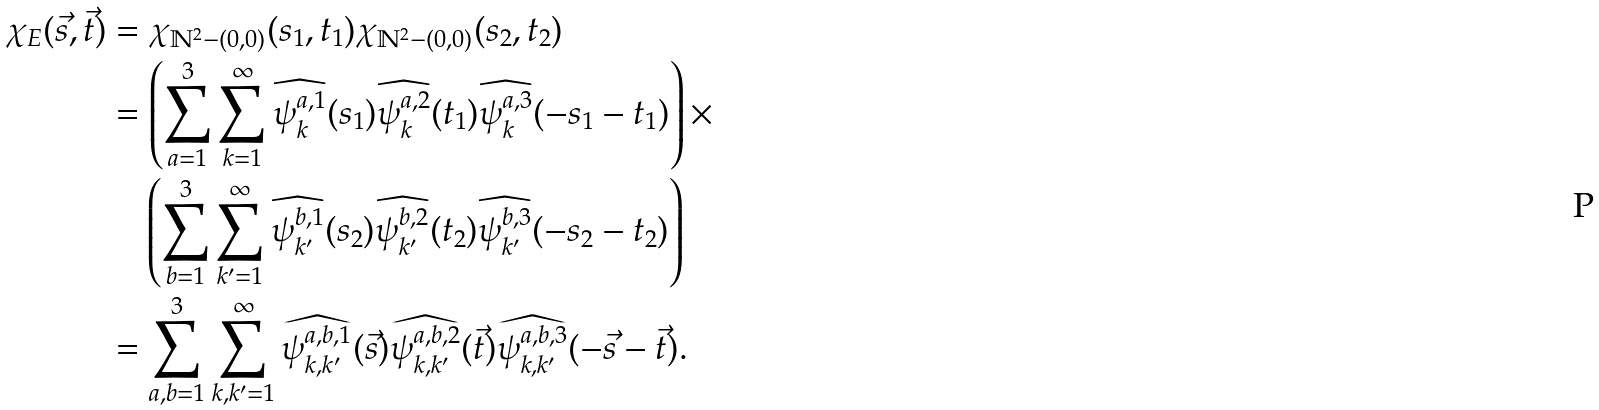Convert formula to latex. <formula><loc_0><loc_0><loc_500><loc_500>\chi _ { E } ( \vec { s } , \vec { t } ) & = \chi _ { \mathbb { N } ^ { 2 } - ( 0 , 0 ) } ( s _ { 1 } , t _ { 1 } ) \chi _ { \mathbb { N } ^ { 2 } - ( 0 , 0 ) } ( s _ { 2 } , t _ { 2 } ) \\ & = \left ( \sum _ { a = 1 } ^ { 3 } \sum _ { k = 1 } ^ { \infty } \widehat { \psi ^ { a , 1 } _ { k } } ( s _ { 1 } ) \widehat { \psi ^ { a , 2 } _ { k } } ( t _ { 1 } ) \widehat { \psi ^ { a , 3 } _ { k } } ( - s _ { 1 } - t _ { 1 } ) \right ) \times \\ & \quad \left ( \sum _ { b = 1 } ^ { 3 } \sum _ { k ^ { \prime } = 1 } ^ { \infty } \widehat { \psi ^ { b , 1 } _ { k ^ { \prime } } } ( s _ { 2 } ) \widehat { \psi ^ { b , 2 } _ { k ^ { \prime } } } ( t _ { 2 } ) \widehat { \psi ^ { b , 3 } _ { k ^ { \prime } } } ( - s _ { 2 } - t _ { 2 } ) \right ) \\ & = \sum _ { a , b = 1 } ^ { 3 } \sum _ { k , k ^ { \prime } = 1 } ^ { \infty } \widehat { \psi ^ { a , b , 1 } _ { k , k ^ { \prime } } } ( \vec { s } ) \widehat { \psi ^ { a , b , 2 } _ { k , k ^ { \prime } } } ( \vec { t } ) \widehat { \psi ^ { a , b , 3 } _ { k , k ^ { \prime } } } ( - \vec { s } - \vec { t } ) .</formula> 